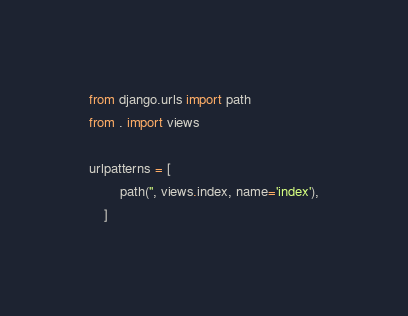<code> <loc_0><loc_0><loc_500><loc_500><_Python_>from django.urls import path
from . import views

urlpatterns = [
        path('', views.index, name='index'),
    ]
</code> 